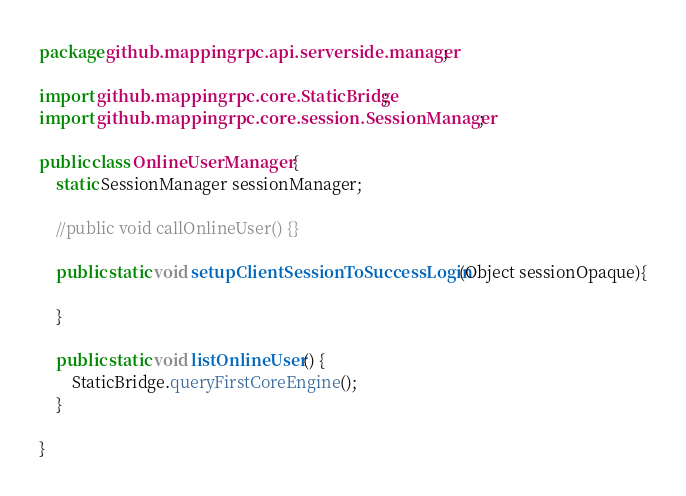Convert code to text. <code><loc_0><loc_0><loc_500><loc_500><_Java_>package github.mappingrpc.api.serverside.manager;

import github.mappingrpc.core.StaticBridge;
import github.mappingrpc.core.session.SessionManager;

public class OnlineUserManager {
	static SessionManager sessionManager;

	//public void callOnlineUser() {}

	public static void setupClientSessionToSuccessLogin(Object sessionOpaque){
		
	}
	
	public static void listOnlineUser() {
		StaticBridge.queryFirstCoreEngine();
	}

}
</code> 